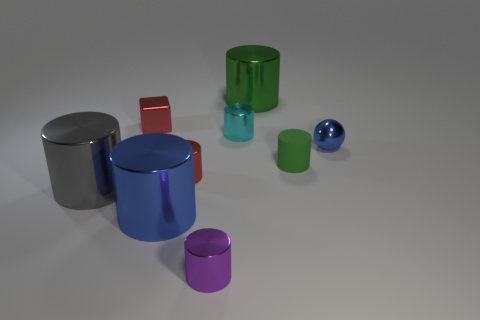Subtract all green cubes. How many green cylinders are left? 2 Subtract 2 cylinders. How many cylinders are left? 5 Subtract all small purple metal cylinders. How many cylinders are left? 6 Add 1 cyan rubber cylinders. How many objects exist? 10 Subtract all purple cylinders. How many cylinders are left? 6 Subtract all blocks. How many objects are left? 8 Subtract all red cylinders. Subtract all red blocks. How many cylinders are left? 6 Add 8 green matte cylinders. How many green matte cylinders are left? 9 Add 5 yellow rubber things. How many yellow rubber things exist? 5 Subtract 0 cyan blocks. How many objects are left? 9 